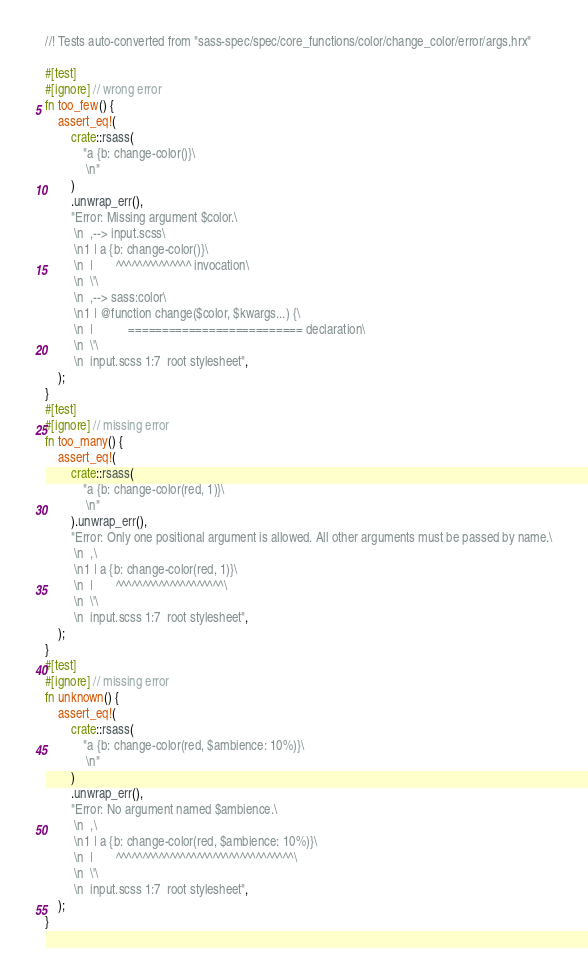<code> <loc_0><loc_0><loc_500><loc_500><_Rust_>//! Tests auto-converted from "sass-spec/spec/core_functions/color/change_color/error/args.hrx"

#[test]
#[ignore] // wrong error
fn too_few() {
    assert_eq!(
        crate::rsass(
            "a {b: change-color()}\
             \n"
        )
        .unwrap_err(),
        "Error: Missing argument $color.\
         \n  ,--> input.scss\
         \n1 | a {b: change-color()}\
         \n  |       ^^^^^^^^^^^^^^ invocation\
         \n  \'\
         \n  ,--> sass:color\
         \n1 | @function change($color, $kwargs...) {\
         \n  |           ========================== declaration\
         \n  \'\
         \n  input.scss 1:7  root stylesheet",
    );
}
#[test]
#[ignore] // missing error
fn too_many() {
    assert_eq!(
        crate::rsass(
            "a {b: change-color(red, 1)}\
             \n"
        ).unwrap_err(),
        "Error: Only one positional argument is allowed. All other arguments must be passed by name.\
         \n  ,\
         \n1 | a {b: change-color(red, 1)}\
         \n  |       ^^^^^^^^^^^^^^^^^^^^\
         \n  \'\
         \n  input.scss 1:7  root stylesheet",
    );
}
#[test]
#[ignore] // missing error
fn unknown() {
    assert_eq!(
        crate::rsass(
            "a {b: change-color(red, $ambience: 10%)}\
             \n"
        )
        .unwrap_err(),
        "Error: No argument named $ambience.\
         \n  ,\
         \n1 | a {b: change-color(red, $ambience: 10%)}\
         \n  |       ^^^^^^^^^^^^^^^^^^^^^^^^^^^^^^^^^\
         \n  \'\
         \n  input.scss 1:7  root stylesheet",
    );
}
</code> 